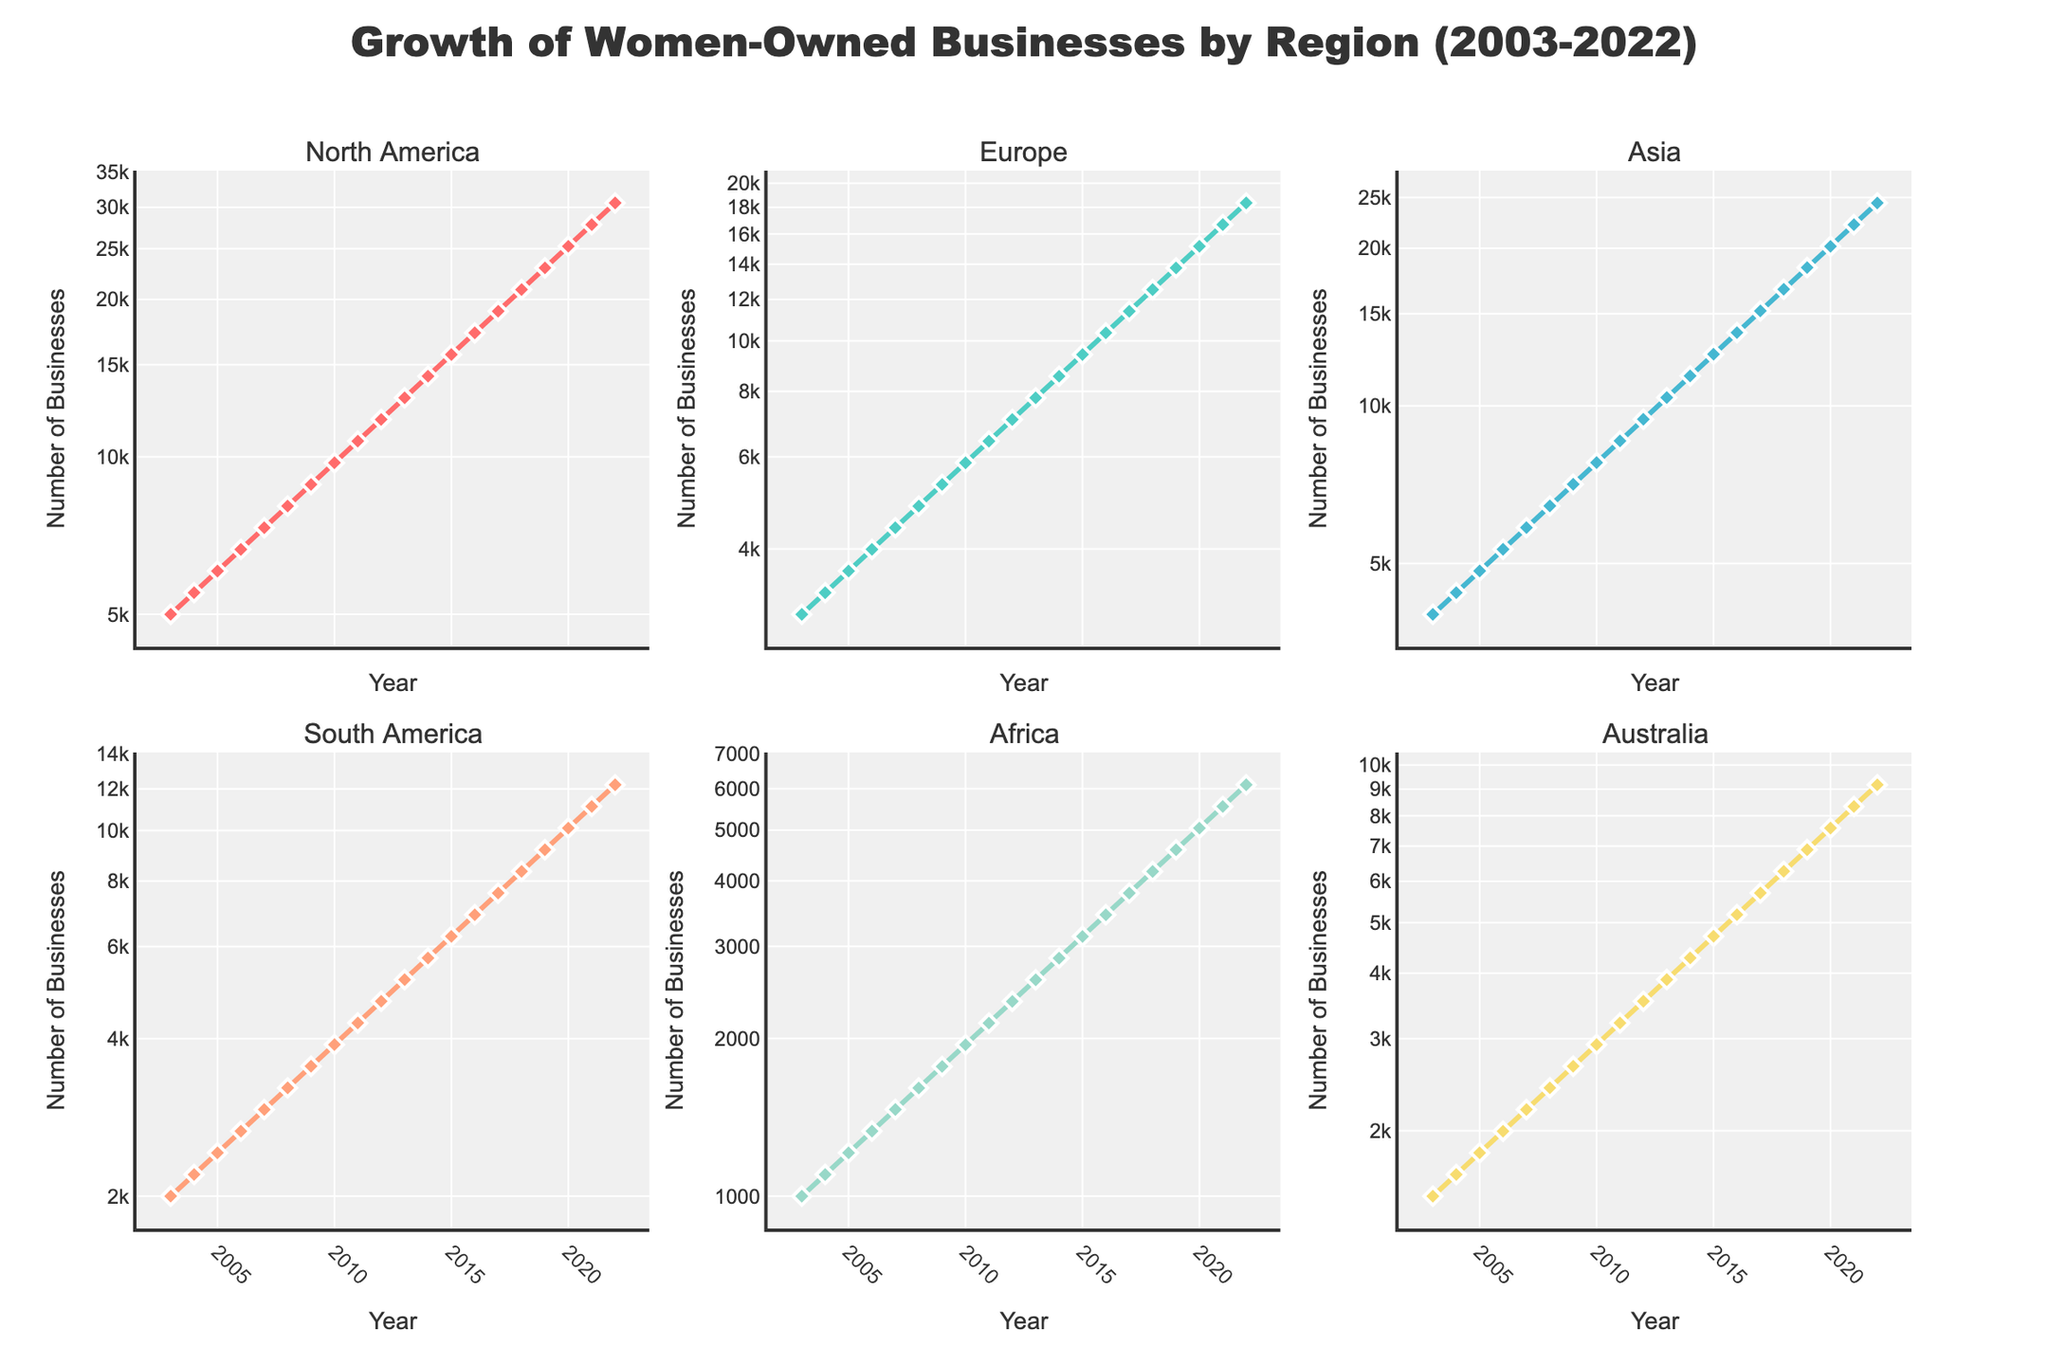what is the title of the figure? The title of the figure is placed centrally at the top of the plot and it combines the subject of growth with the specifics on women-owned businesses across various regions over time.
Answer: Growth of Women-Owned Businesses by Region (2003-2022) how many subplots does the figure contain? The figure consists of multiple parts, each dedicated to a region; examining the layout, there are two rows and three columns of plots, summing up the total number displayed.
Answer: 6 which region shows the highest growth in the number of businesses from 2003 to 2022? To determine this, look at the trend lines in each subplot and identify which one has the most significant increase, taking into account the logarithmic scale on the y-axis. North America shows the highest increase as evidenced by its highest end value in the plot.
Answer: North America between which years did the number of women-owned businesses in Africa more than double? Observing the subplot for Africa and using the logarithmic growth points, find where the values go from around 1500 to approximately doubling that value. This doubling occurs between 2011 (2140) and 2022 (6103).
Answer: 2011 and 2022 how do growth rates compare between Europe and Asia over the past 20 years? For this question, examine the increments on the logarithmic y-axes of both subplots, noting that both regions start close but diverge in values with Asia reaching higher counts in the end. Asia shows a faster rate of growth compared to Europe.
Answer: Asia has a faster growth rate than Europe which two regions have similar growth trajectories over the years? By closely analyzing the proximity and slope of the lines in their respective subplots, it's apparent that South America and Australia have comparable trends. Both lines follow a similar path with similar values throughout the timeline.
Answer: South America and Australia from 2005 to 2015, how many times did the number of women-owned businesses increase in Australia? Check the subplot for Australia, identifying the values at 2005 and 2015, then divide the later value by the earlier one. The number of businesses went from 1815 in 2005 to 4708 in 2015, giving a ratio of approximately 2.59.
Answer: About 2.59 times which region had the smallest relative growth from 2003 to 2022? To determine this, compare the start and end points for all regions on their respective logarithmic plots and see which region has the least change in values. Africa's businesses increased from 1000 to 6103, a smaller growth factor relative to other regions.
Answer: Africa what trend is noticeable about North America's growth pattern after 2015? Focus on the subplot for North America and study the slope from 2015 onwards. The trend line becomes steeper after 2015, indicating an accelerated growth rate.
Answer: Accelerated growth what is the number of women-owned businesses in Europe in 2010? Locate the subplot for Europe and find the data point for 2010. The plot shows the value around 5845 businesses.
Answer: 5845 